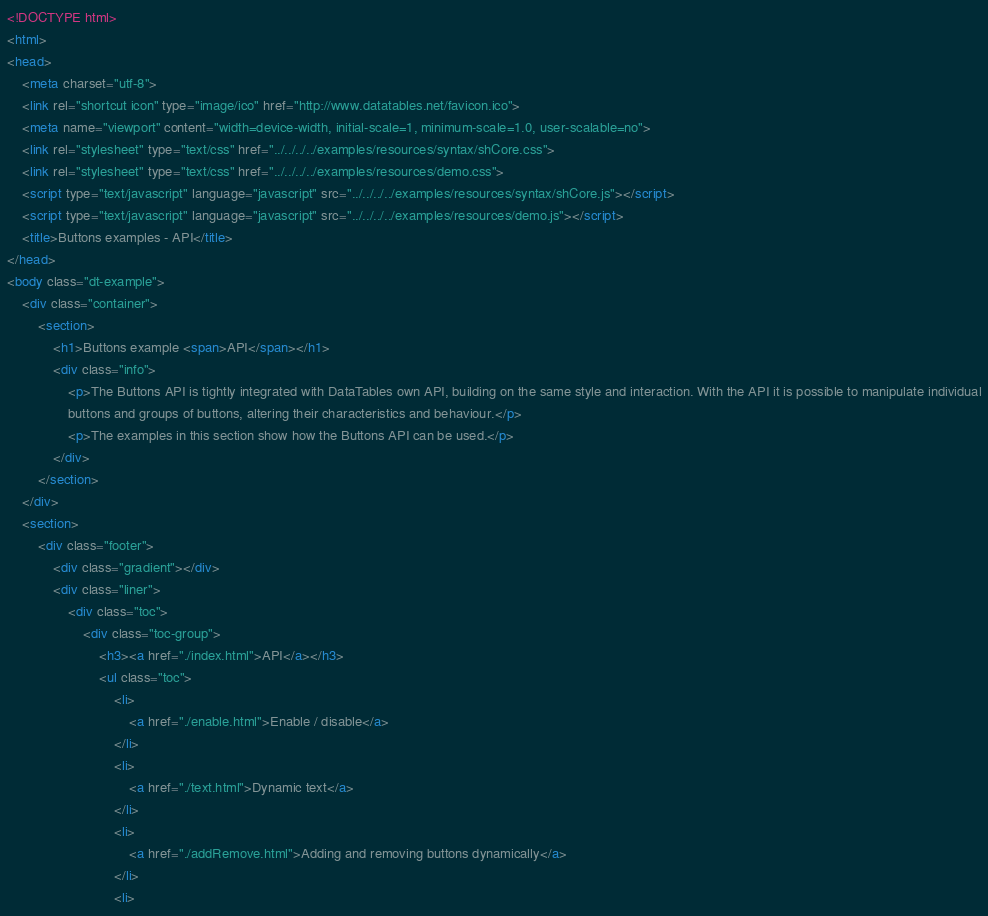Convert code to text. <code><loc_0><loc_0><loc_500><loc_500><_HTML_><!DOCTYPE html>
<html>
<head>
	<meta charset="utf-8">
	<link rel="shortcut icon" type="image/ico" href="http://www.datatables.net/favicon.ico">
	<meta name="viewport" content="width=device-width, initial-scale=1, minimum-scale=1.0, user-scalable=no">
	<link rel="stylesheet" type="text/css" href="../../../../examples/resources/syntax/shCore.css">
	<link rel="stylesheet" type="text/css" href="../../../../examples/resources/demo.css">
	<script type="text/javascript" language="javascript" src="../../../../examples/resources/syntax/shCore.js"></script>
	<script type="text/javascript" language="javascript" src="../../../../examples/resources/demo.js"></script>
	<title>Buttons examples - API</title>
</head>
<body class="dt-example">
	<div class="container">
		<section>
			<h1>Buttons example <span>API</span></h1>
			<div class="info">
				<p>The Buttons API is tightly integrated with DataTables own API, building on the same style and interaction. With the API it is possible to manipulate individual
				buttons and groups of buttons, altering their characteristics and behaviour.</p>
				<p>The examples in this section show how the Buttons API can be used.</p>
			</div>
		</section>
	</div>
	<section>
		<div class="footer">
			<div class="gradient"></div>
			<div class="liner">
				<div class="toc">
					<div class="toc-group">
						<h3><a href="./index.html">API</a></h3>
						<ul class="toc">
							<li>
								<a href="./enable.html">Enable / disable</a>
							</li>
							<li>
								<a href="./text.html">Dynamic text</a>
							</li>
							<li>
								<a href="./addRemove.html">Adding and removing buttons dynamically</a>
							</li>
							<li></code> 